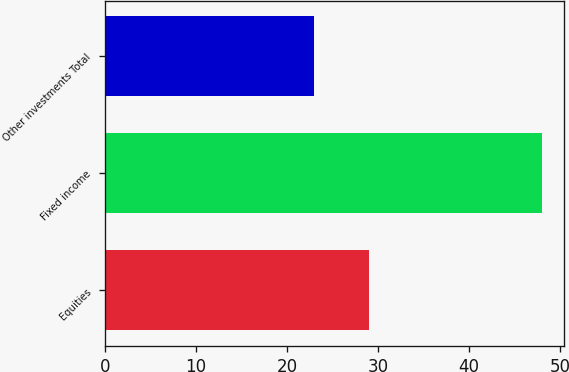<chart> <loc_0><loc_0><loc_500><loc_500><bar_chart><fcel>Equities<fcel>Fixed income<fcel>Other investments Total<nl><fcel>29<fcel>48<fcel>23<nl></chart> 